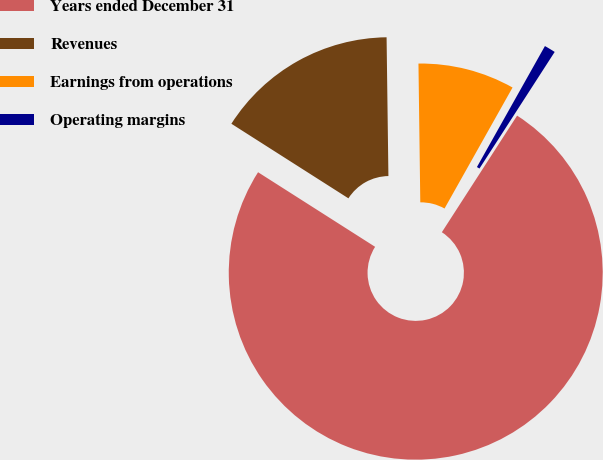Convert chart to OTSL. <chart><loc_0><loc_0><loc_500><loc_500><pie_chart><fcel>Years ended December 31<fcel>Revenues<fcel>Earnings from operations<fcel>Operating margins<nl><fcel>74.91%<fcel>15.76%<fcel>8.36%<fcel>0.97%<nl></chart> 